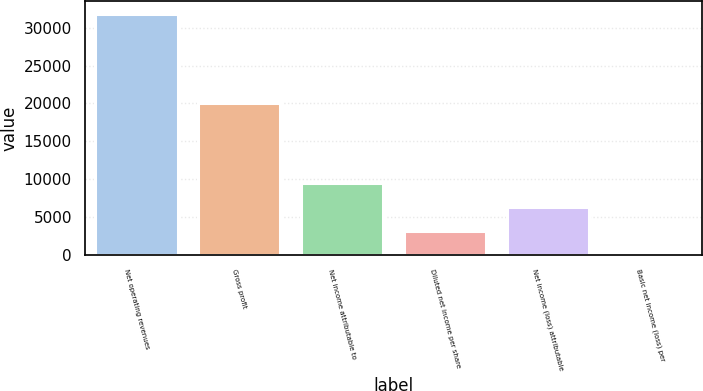<chart> <loc_0><loc_0><loc_500><loc_500><bar_chart><fcel>Net operating revenues<fcel>Gross profit<fcel>Net income attributable to<fcel>Diluted net income per share<fcel>Net income (loss) attributable<fcel>Basic net income (loss) per<nl><fcel>31856<fcel>20086<fcel>9557<fcel>3185.86<fcel>6371.43<fcel>0.29<nl></chart> 